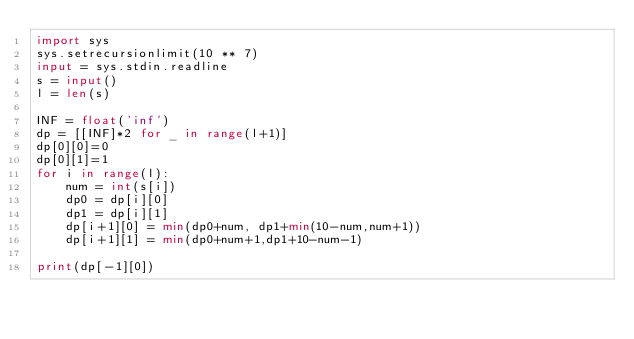<code> <loc_0><loc_0><loc_500><loc_500><_Python_>import sys
sys.setrecursionlimit(10 ** 7)
input = sys.stdin.readline
s = input()
l = len(s)

INF = float('inf')
dp = [[INF]*2 for _ in range(l+1)]
dp[0][0]=0
dp[0][1]=1
for i in range(l):
    num = int(s[i])
    dp0 = dp[i][0]
    dp1 = dp[i][1]
    dp[i+1][0] = min(dp0+num, dp1+min(10-num,num+1))
    dp[i+1][1] = min(dp0+num+1,dp1+10-num-1)

print(dp[-1][0])
</code> 